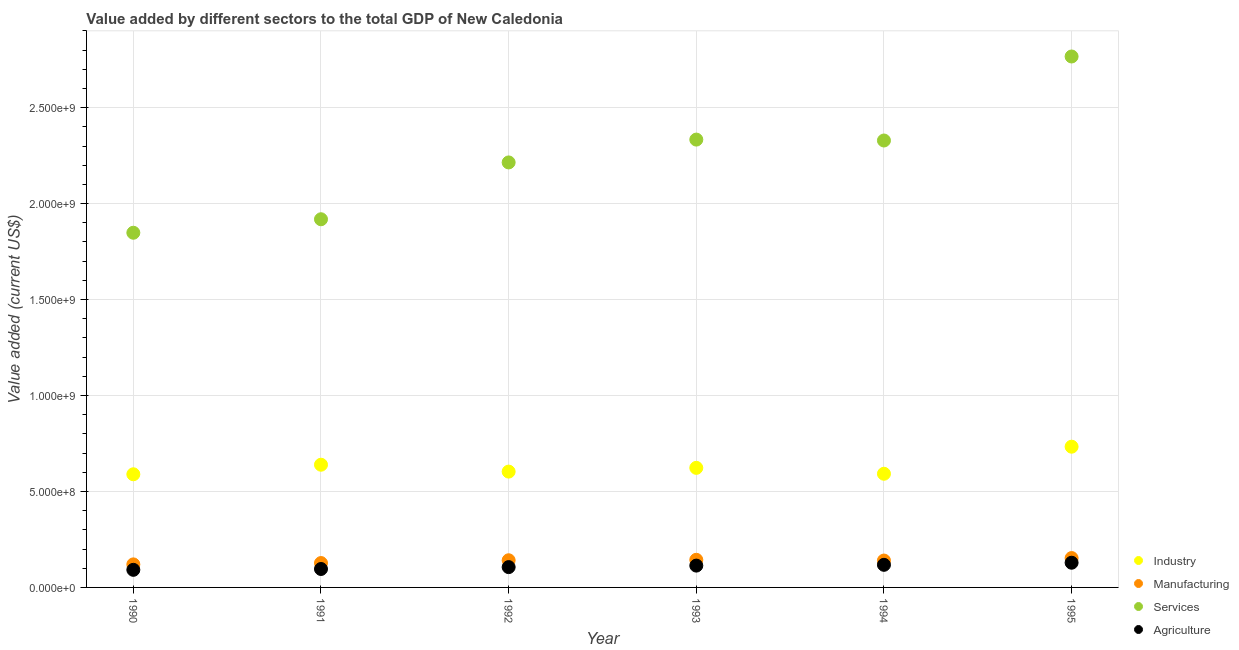What is the value added by services sector in 1993?
Provide a short and direct response. 2.33e+09. Across all years, what is the maximum value added by services sector?
Make the answer very short. 2.77e+09. Across all years, what is the minimum value added by manufacturing sector?
Your answer should be compact. 1.20e+08. In which year was the value added by manufacturing sector maximum?
Offer a terse response. 1995. What is the total value added by industrial sector in the graph?
Your answer should be very brief. 3.78e+09. What is the difference between the value added by services sector in 1991 and that in 1993?
Offer a very short reply. -4.15e+08. What is the difference between the value added by services sector in 1993 and the value added by industrial sector in 1990?
Provide a short and direct response. 1.74e+09. What is the average value added by manufacturing sector per year?
Offer a very short reply. 1.38e+08. In the year 1995, what is the difference between the value added by agricultural sector and value added by services sector?
Your answer should be very brief. -2.64e+09. What is the ratio of the value added by agricultural sector in 1990 to that in 1995?
Your answer should be compact. 0.71. Is the difference between the value added by agricultural sector in 1993 and 1995 greater than the difference between the value added by services sector in 1993 and 1995?
Provide a short and direct response. Yes. What is the difference between the highest and the second highest value added by industrial sector?
Offer a very short reply. 9.39e+07. What is the difference between the highest and the lowest value added by industrial sector?
Your answer should be compact. 1.44e+08. In how many years, is the value added by services sector greater than the average value added by services sector taken over all years?
Give a very brief answer. 3. Is the sum of the value added by manufacturing sector in 1992 and 1993 greater than the maximum value added by agricultural sector across all years?
Your answer should be very brief. Yes. Is it the case that in every year, the sum of the value added by agricultural sector and value added by industrial sector is greater than the sum of value added by manufacturing sector and value added by services sector?
Provide a short and direct response. No. Is it the case that in every year, the sum of the value added by industrial sector and value added by manufacturing sector is greater than the value added by services sector?
Provide a short and direct response. No. Does the value added by manufacturing sector monotonically increase over the years?
Provide a short and direct response. No. How many years are there in the graph?
Your answer should be very brief. 6. What is the difference between two consecutive major ticks on the Y-axis?
Make the answer very short. 5.00e+08. Are the values on the major ticks of Y-axis written in scientific E-notation?
Your answer should be compact. Yes. Does the graph contain any zero values?
Your response must be concise. No. How many legend labels are there?
Your answer should be very brief. 4. What is the title of the graph?
Offer a very short reply. Value added by different sectors to the total GDP of New Caledonia. Does "France" appear as one of the legend labels in the graph?
Give a very brief answer. No. What is the label or title of the Y-axis?
Your answer should be compact. Value added (current US$). What is the Value added (current US$) of Industry in 1990?
Your answer should be compact. 5.90e+08. What is the Value added (current US$) of Manufacturing in 1990?
Ensure brevity in your answer.  1.20e+08. What is the Value added (current US$) in Services in 1990?
Make the answer very short. 1.85e+09. What is the Value added (current US$) of Agriculture in 1990?
Offer a terse response. 9.17e+07. What is the Value added (current US$) of Industry in 1991?
Offer a terse response. 6.39e+08. What is the Value added (current US$) in Manufacturing in 1991?
Make the answer very short. 1.27e+08. What is the Value added (current US$) in Services in 1991?
Your answer should be compact. 1.92e+09. What is the Value added (current US$) in Agriculture in 1991?
Offer a very short reply. 9.60e+07. What is the Value added (current US$) of Industry in 1992?
Provide a short and direct response. 6.03e+08. What is the Value added (current US$) in Manufacturing in 1992?
Keep it short and to the point. 1.42e+08. What is the Value added (current US$) of Services in 1992?
Make the answer very short. 2.21e+09. What is the Value added (current US$) in Agriculture in 1992?
Your answer should be very brief. 1.06e+08. What is the Value added (current US$) of Industry in 1993?
Make the answer very short. 6.23e+08. What is the Value added (current US$) in Manufacturing in 1993?
Your answer should be compact. 1.44e+08. What is the Value added (current US$) in Services in 1993?
Keep it short and to the point. 2.33e+09. What is the Value added (current US$) of Agriculture in 1993?
Keep it short and to the point. 1.14e+08. What is the Value added (current US$) of Industry in 1994?
Offer a terse response. 5.92e+08. What is the Value added (current US$) in Manufacturing in 1994?
Your response must be concise. 1.40e+08. What is the Value added (current US$) in Services in 1994?
Your answer should be compact. 2.33e+09. What is the Value added (current US$) in Agriculture in 1994?
Ensure brevity in your answer.  1.18e+08. What is the Value added (current US$) of Industry in 1995?
Your answer should be compact. 7.33e+08. What is the Value added (current US$) in Manufacturing in 1995?
Your answer should be compact. 1.53e+08. What is the Value added (current US$) of Services in 1995?
Ensure brevity in your answer.  2.77e+09. What is the Value added (current US$) in Agriculture in 1995?
Ensure brevity in your answer.  1.29e+08. Across all years, what is the maximum Value added (current US$) of Industry?
Offer a very short reply. 7.33e+08. Across all years, what is the maximum Value added (current US$) of Manufacturing?
Provide a short and direct response. 1.53e+08. Across all years, what is the maximum Value added (current US$) in Services?
Your response must be concise. 2.77e+09. Across all years, what is the maximum Value added (current US$) of Agriculture?
Make the answer very short. 1.29e+08. Across all years, what is the minimum Value added (current US$) of Industry?
Your answer should be very brief. 5.90e+08. Across all years, what is the minimum Value added (current US$) in Manufacturing?
Offer a terse response. 1.20e+08. Across all years, what is the minimum Value added (current US$) of Services?
Give a very brief answer. 1.85e+09. Across all years, what is the minimum Value added (current US$) in Agriculture?
Keep it short and to the point. 9.17e+07. What is the total Value added (current US$) of Industry in the graph?
Offer a terse response. 3.78e+09. What is the total Value added (current US$) in Manufacturing in the graph?
Offer a very short reply. 8.26e+08. What is the total Value added (current US$) in Services in the graph?
Provide a short and direct response. 1.34e+1. What is the total Value added (current US$) in Agriculture in the graph?
Your answer should be very brief. 6.54e+08. What is the difference between the Value added (current US$) in Industry in 1990 and that in 1991?
Provide a succinct answer. -4.98e+07. What is the difference between the Value added (current US$) of Manufacturing in 1990 and that in 1991?
Your answer should be compact. -6.93e+06. What is the difference between the Value added (current US$) in Services in 1990 and that in 1991?
Provide a short and direct response. -7.03e+07. What is the difference between the Value added (current US$) of Agriculture in 1990 and that in 1991?
Your answer should be compact. -4.37e+06. What is the difference between the Value added (current US$) in Industry in 1990 and that in 1992?
Your answer should be very brief. -1.39e+07. What is the difference between the Value added (current US$) of Manufacturing in 1990 and that in 1992?
Your answer should be compact. -2.15e+07. What is the difference between the Value added (current US$) of Services in 1990 and that in 1992?
Ensure brevity in your answer.  -3.66e+08. What is the difference between the Value added (current US$) in Agriculture in 1990 and that in 1992?
Offer a terse response. -1.42e+07. What is the difference between the Value added (current US$) of Industry in 1990 and that in 1993?
Offer a very short reply. -3.34e+07. What is the difference between the Value added (current US$) of Manufacturing in 1990 and that in 1993?
Offer a terse response. -2.39e+07. What is the difference between the Value added (current US$) of Services in 1990 and that in 1993?
Ensure brevity in your answer.  -4.85e+08. What is the difference between the Value added (current US$) in Agriculture in 1990 and that in 1993?
Provide a short and direct response. -2.20e+07. What is the difference between the Value added (current US$) of Industry in 1990 and that in 1994?
Offer a terse response. -2.67e+06. What is the difference between the Value added (current US$) in Manufacturing in 1990 and that in 1994?
Provide a succinct answer. -2.00e+07. What is the difference between the Value added (current US$) of Services in 1990 and that in 1994?
Offer a terse response. -4.81e+08. What is the difference between the Value added (current US$) in Agriculture in 1990 and that in 1994?
Keep it short and to the point. -2.61e+07. What is the difference between the Value added (current US$) in Industry in 1990 and that in 1995?
Your answer should be very brief. -1.44e+08. What is the difference between the Value added (current US$) in Manufacturing in 1990 and that in 1995?
Provide a succinct answer. -3.29e+07. What is the difference between the Value added (current US$) of Services in 1990 and that in 1995?
Make the answer very short. -9.18e+08. What is the difference between the Value added (current US$) of Agriculture in 1990 and that in 1995?
Make the answer very short. -3.70e+07. What is the difference between the Value added (current US$) in Industry in 1991 and that in 1992?
Ensure brevity in your answer.  3.59e+07. What is the difference between the Value added (current US$) in Manufacturing in 1991 and that in 1992?
Offer a very short reply. -1.45e+07. What is the difference between the Value added (current US$) in Services in 1991 and that in 1992?
Provide a succinct answer. -2.96e+08. What is the difference between the Value added (current US$) of Agriculture in 1991 and that in 1992?
Keep it short and to the point. -9.78e+06. What is the difference between the Value added (current US$) of Industry in 1991 and that in 1993?
Offer a very short reply. 1.64e+07. What is the difference between the Value added (current US$) of Manufacturing in 1991 and that in 1993?
Provide a short and direct response. -1.69e+07. What is the difference between the Value added (current US$) of Services in 1991 and that in 1993?
Provide a succinct answer. -4.15e+08. What is the difference between the Value added (current US$) in Agriculture in 1991 and that in 1993?
Ensure brevity in your answer.  -1.76e+07. What is the difference between the Value added (current US$) in Industry in 1991 and that in 1994?
Your answer should be very brief. 4.71e+07. What is the difference between the Value added (current US$) of Manufacturing in 1991 and that in 1994?
Your response must be concise. -1.31e+07. What is the difference between the Value added (current US$) in Services in 1991 and that in 1994?
Make the answer very short. -4.10e+08. What is the difference between the Value added (current US$) of Agriculture in 1991 and that in 1994?
Provide a short and direct response. -2.17e+07. What is the difference between the Value added (current US$) of Industry in 1991 and that in 1995?
Ensure brevity in your answer.  -9.39e+07. What is the difference between the Value added (current US$) of Manufacturing in 1991 and that in 1995?
Your response must be concise. -2.60e+07. What is the difference between the Value added (current US$) in Services in 1991 and that in 1995?
Provide a succinct answer. -8.48e+08. What is the difference between the Value added (current US$) in Agriculture in 1991 and that in 1995?
Give a very brief answer. -3.27e+07. What is the difference between the Value added (current US$) of Industry in 1992 and that in 1993?
Give a very brief answer. -1.95e+07. What is the difference between the Value added (current US$) in Manufacturing in 1992 and that in 1993?
Make the answer very short. -2.42e+06. What is the difference between the Value added (current US$) in Services in 1992 and that in 1993?
Offer a very short reply. -1.19e+08. What is the difference between the Value added (current US$) in Agriculture in 1992 and that in 1993?
Offer a very short reply. -7.86e+06. What is the difference between the Value added (current US$) of Industry in 1992 and that in 1994?
Make the answer very short. 1.12e+07. What is the difference between the Value added (current US$) of Manufacturing in 1992 and that in 1994?
Ensure brevity in your answer.  1.45e+06. What is the difference between the Value added (current US$) of Services in 1992 and that in 1994?
Offer a terse response. -1.14e+08. What is the difference between the Value added (current US$) in Agriculture in 1992 and that in 1994?
Your response must be concise. -1.20e+07. What is the difference between the Value added (current US$) in Industry in 1992 and that in 1995?
Give a very brief answer. -1.30e+08. What is the difference between the Value added (current US$) in Manufacturing in 1992 and that in 1995?
Offer a very short reply. -1.15e+07. What is the difference between the Value added (current US$) of Services in 1992 and that in 1995?
Ensure brevity in your answer.  -5.52e+08. What is the difference between the Value added (current US$) in Agriculture in 1992 and that in 1995?
Provide a succinct answer. -2.29e+07. What is the difference between the Value added (current US$) in Industry in 1993 and that in 1994?
Your answer should be compact. 3.08e+07. What is the difference between the Value added (current US$) of Manufacturing in 1993 and that in 1994?
Your response must be concise. 3.86e+06. What is the difference between the Value added (current US$) in Services in 1993 and that in 1994?
Your response must be concise. 4.76e+06. What is the difference between the Value added (current US$) in Agriculture in 1993 and that in 1994?
Your answer should be very brief. -4.11e+06. What is the difference between the Value added (current US$) of Industry in 1993 and that in 1995?
Offer a terse response. -1.10e+08. What is the difference between the Value added (current US$) of Manufacturing in 1993 and that in 1995?
Ensure brevity in your answer.  -9.07e+06. What is the difference between the Value added (current US$) in Services in 1993 and that in 1995?
Your response must be concise. -4.33e+08. What is the difference between the Value added (current US$) in Agriculture in 1993 and that in 1995?
Your answer should be very brief. -1.50e+07. What is the difference between the Value added (current US$) in Industry in 1994 and that in 1995?
Give a very brief answer. -1.41e+08. What is the difference between the Value added (current US$) in Manufacturing in 1994 and that in 1995?
Keep it short and to the point. -1.29e+07. What is the difference between the Value added (current US$) in Services in 1994 and that in 1995?
Offer a terse response. -4.38e+08. What is the difference between the Value added (current US$) of Agriculture in 1994 and that in 1995?
Keep it short and to the point. -1.09e+07. What is the difference between the Value added (current US$) of Industry in 1990 and the Value added (current US$) of Manufacturing in 1991?
Keep it short and to the point. 4.63e+08. What is the difference between the Value added (current US$) of Industry in 1990 and the Value added (current US$) of Services in 1991?
Your answer should be compact. -1.33e+09. What is the difference between the Value added (current US$) in Industry in 1990 and the Value added (current US$) in Agriculture in 1991?
Offer a terse response. 4.94e+08. What is the difference between the Value added (current US$) in Manufacturing in 1990 and the Value added (current US$) in Services in 1991?
Make the answer very short. -1.80e+09. What is the difference between the Value added (current US$) in Manufacturing in 1990 and the Value added (current US$) in Agriculture in 1991?
Your response must be concise. 2.40e+07. What is the difference between the Value added (current US$) of Services in 1990 and the Value added (current US$) of Agriculture in 1991?
Your answer should be compact. 1.75e+09. What is the difference between the Value added (current US$) of Industry in 1990 and the Value added (current US$) of Manufacturing in 1992?
Keep it short and to the point. 4.48e+08. What is the difference between the Value added (current US$) in Industry in 1990 and the Value added (current US$) in Services in 1992?
Offer a terse response. -1.62e+09. What is the difference between the Value added (current US$) in Industry in 1990 and the Value added (current US$) in Agriculture in 1992?
Keep it short and to the point. 4.84e+08. What is the difference between the Value added (current US$) of Manufacturing in 1990 and the Value added (current US$) of Services in 1992?
Provide a short and direct response. -2.09e+09. What is the difference between the Value added (current US$) of Manufacturing in 1990 and the Value added (current US$) of Agriculture in 1992?
Your answer should be very brief. 1.43e+07. What is the difference between the Value added (current US$) in Services in 1990 and the Value added (current US$) in Agriculture in 1992?
Offer a very short reply. 1.74e+09. What is the difference between the Value added (current US$) of Industry in 1990 and the Value added (current US$) of Manufacturing in 1993?
Make the answer very short. 4.46e+08. What is the difference between the Value added (current US$) of Industry in 1990 and the Value added (current US$) of Services in 1993?
Make the answer very short. -1.74e+09. What is the difference between the Value added (current US$) in Industry in 1990 and the Value added (current US$) in Agriculture in 1993?
Offer a very short reply. 4.76e+08. What is the difference between the Value added (current US$) of Manufacturing in 1990 and the Value added (current US$) of Services in 1993?
Give a very brief answer. -2.21e+09. What is the difference between the Value added (current US$) of Manufacturing in 1990 and the Value added (current US$) of Agriculture in 1993?
Offer a terse response. 6.40e+06. What is the difference between the Value added (current US$) of Services in 1990 and the Value added (current US$) of Agriculture in 1993?
Give a very brief answer. 1.73e+09. What is the difference between the Value added (current US$) of Industry in 1990 and the Value added (current US$) of Manufacturing in 1994?
Give a very brief answer. 4.49e+08. What is the difference between the Value added (current US$) of Industry in 1990 and the Value added (current US$) of Services in 1994?
Offer a terse response. -1.74e+09. What is the difference between the Value added (current US$) of Industry in 1990 and the Value added (current US$) of Agriculture in 1994?
Your answer should be compact. 4.72e+08. What is the difference between the Value added (current US$) of Manufacturing in 1990 and the Value added (current US$) of Services in 1994?
Offer a very short reply. -2.21e+09. What is the difference between the Value added (current US$) of Manufacturing in 1990 and the Value added (current US$) of Agriculture in 1994?
Offer a terse response. 2.29e+06. What is the difference between the Value added (current US$) of Services in 1990 and the Value added (current US$) of Agriculture in 1994?
Offer a terse response. 1.73e+09. What is the difference between the Value added (current US$) of Industry in 1990 and the Value added (current US$) of Manufacturing in 1995?
Provide a succinct answer. 4.37e+08. What is the difference between the Value added (current US$) of Industry in 1990 and the Value added (current US$) of Services in 1995?
Provide a short and direct response. -2.18e+09. What is the difference between the Value added (current US$) of Industry in 1990 and the Value added (current US$) of Agriculture in 1995?
Give a very brief answer. 4.61e+08. What is the difference between the Value added (current US$) in Manufacturing in 1990 and the Value added (current US$) in Services in 1995?
Your answer should be compact. -2.65e+09. What is the difference between the Value added (current US$) in Manufacturing in 1990 and the Value added (current US$) in Agriculture in 1995?
Ensure brevity in your answer.  -8.63e+06. What is the difference between the Value added (current US$) of Services in 1990 and the Value added (current US$) of Agriculture in 1995?
Provide a short and direct response. 1.72e+09. What is the difference between the Value added (current US$) of Industry in 1991 and the Value added (current US$) of Manufacturing in 1992?
Keep it short and to the point. 4.98e+08. What is the difference between the Value added (current US$) in Industry in 1991 and the Value added (current US$) in Services in 1992?
Give a very brief answer. -1.58e+09. What is the difference between the Value added (current US$) in Industry in 1991 and the Value added (current US$) in Agriculture in 1992?
Your answer should be very brief. 5.34e+08. What is the difference between the Value added (current US$) in Manufacturing in 1991 and the Value added (current US$) in Services in 1992?
Offer a terse response. -2.09e+09. What is the difference between the Value added (current US$) in Manufacturing in 1991 and the Value added (current US$) in Agriculture in 1992?
Provide a short and direct response. 2.12e+07. What is the difference between the Value added (current US$) of Services in 1991 and the Value added (current US$) of Agriculture in 1992?
Give a very brief answer. 1.81e+09. What is the difference between the Value added (current US$) in Industry in 1991 and the Value added (current US$) in Manufacturing in 1993?
Your response must be concise. 4.95e+08. What is the difference between the Value added (current US$) in Industry in 1991 and the Value added (current US$) in Services in 1993?
Your answer should be compact. -1.69e+09. What is the difference between the Value added (current US$) in Industry in 1991 and the Value added (current US$) in Agriculture in 1993?
Offer a terse response. 5.26e+08. What is the difference between the Value added (current US$) of Manufacturing in 1991 and the Value added (current US$) of Services in 1993?
Keep it short and to the point. -2.21e+09. What is the difference between the Value added (current US$) in Manufacturing in 1991 and the Value added (current US$) in Agriculture in 1993?
Provide a succinct answer. 1.33e+07. What is the difference between the Value added (current US$) of Services in 1991 and the Value added (current US$) of Agriculture in 1993?
Keep it short and to the point. 1.80e+09. What is the difference between the Value added (current US$) in Industry in 1991 and the Value added (current US$) in Manufacturing in 1994?
Give a very brief answer. 4.99e+08. What is the difference between the Value added (current US$) in Industry in 1991 and the Value added (current US$) in Services in 1994?
Provide a succinct answer. -1.69e+09. What is the difference between the Value added (current US$) of Industry in 1991 and the Value added (current US$) of Agriculture in 1994?
Provide a short and direct response. 5.22e+08. What is the difference between the Value added (current US$) in Manufacturing in 1991 and the Value added (current US$) in Services in 1994?
Your response must be concise. -2.20e+09. What is the difference between the Value added (current US$) of Manufacturing in 1991 and the Value added (current US$) of Agriculture in 1994?
Your answer should be compact. 9.22e+06. What is the difference between the Value added (current US$) in Services in 1991 and the Value added (current US$) in Agriculture in 1994?
Keep it short and to the point. 1.80e+09. What is the difference between the Value added (current US$) of Industry in 1991 and the Value added (current US$) of Manufacturing in 1995?
Your answer should be very brief. 4.86e+08. What is the difference between the Value added (current US$) in Industry in 1991 and the Value added (current US$) in Services in 1995?
Offer a terse response. -2.13e+09. What is the difference between the Value added (current US$) of Industry in 1991 and the Value added (current US$) of Agriculture in 1995?
Offer a very short reply. 5.11e+08. What is the difference between the Value added (current US$) of Manufacturing in 1991 and the Value added (current US$) of Services in 1995?
Your answer should be very brief. -2.64e+09. What is the difference between the Value added (current US$) of Manufacturing in 1991 and the Value added (current US$) of Agriculture in 1995?
Keep it short and to the point. -1.70e+06. What is the difference between the Value added (current US$) of Services in 1991 and the Value added (current US$) of Agriculture in 1995?
Your answer should be very brief. 1.79e+09. What is the difference between the Value added (current US$) of Industry in 1992 and the Value added (current US$) of Manufacturing in 1993?
Provide a short and direct response. 4.60e+08. What is the difference between the Value added (current US$) in Industry in 1992 and the Value added (current US$) in Services in 1993?
Your response must be concise. -1.73e+09. What is the difference between the Value added (current US$) of Industry in 1992 and the Value added (current US$) of Agriculture in 1993?
Keep it short and to the point. 4.90e+08. What is the difference between the Value added (current US$) in Manufacturing in 1992 and the Value added (current US$) in Services in 1993?
Make the answer very short. -2.19e+09. What is the difference between the Value added (current US$) of Manufacturing in 1992 and the Value added (current US$) of Agriculture in 1993?
Provide a succinct answer. 2.79e+07. What is the difference between the Value added (current US$) in Services in 1992 and the Value added (current US$) in Agriculture in 1993?
Your answer should be compact. 2.10e+09. What is the difference between the Value added (current US$) of Industry in 1992 and the Value added (current US$) of Manufacturing in 1994?
Ensure brevity in your answer.  4.63e+08. What is the difference between the Value added (current US$) of Industry in 1992 and the Value added (current US$) of Services in 1994?
Ensure brevity in your answer.  -1.73e+09. What is the difference between the Value added (current US$) of Industry in 1992 and the Value added (current US$) of Agriculture in 1994?
Provide a succinct answer. 4.86e+08. What is the difference between the Value added (current US$) in Manufacturing in 1992 and the Value added (current US$) in Services in 1994?
Your response must be concise. -2.19e+09. What is the difference between the Value added (current US$) of Manufacturing in 1992 and the Value added (current US$) of Agriculture in 1994?
Ensure brevity in your answer.  2.37e+07. What is the difference between the Value added (current US$) of Services in 1992 and the Value added (current US$) of Agriculture in 1994?
Give a very brief answer. 2.10e+09. What is the difference between the Value added (current US$) in Industry in 1992 and the Value added (current US$) in Manufacturing in 1995?
Make the answer very short. 4.50e+08. What is the difference between the Value added (current US$) of Industry in 1992 and the Value added (current US$) of Services in 1995?
Keep it short and to the point. -2.16e+09. What is the difference between the Value added (current US$) of Industry in 1992 and the Value added (current US$) of Agriculture in 1995?
Offer a very short reply. 4.75e+08. What is the difference between the Value added (current US$) in Manufacturing in 1992 and the Value added (current US$) in Services in 1995?
Your answer should be compact. -2.62e+09. What is the difference between the Value added (current US$) of Manufacturing in 1992 and the Value added (current US$) of Agriculture in 1995?
Your answer should be very brief. 1.28e+07. What is the difference between the Value added (current US$) of Services in 1992 and the Value added (current US$) of Agriculture in 1995?
Make the answer very short. 2.09e+09. What is the difference between the Value added (current US$) in Industry in 1993 and the Value added (current US$) in Manufacturing in 1994?
Keep it short and to the point. 4.83e+08. What is the difference between the Value added (current US$) in Industry in 1993 and the Value added (current US$) in Services in 1994?
Offer a terse response. -1.71e+09. What is the difference between the Value added (current US$) of Industry in 1993 and the Value added (current US$) of Agriculture in 1994?
Give a very brief answer. 5.05e+08. What is the difference between the Value added (current US$) in Manufacturing in 1993 and the Value added (current US$) in Services in 1994?
Your answer should be compact. -2.18e+09. What is the difference between the Value added (current US$) of Manufacturing in 1993 and the Value added (current US$) of Agriculture in 1994?
Ensure brevity in your answer.  2.62e+07. What is the difference between the Value added (current US$) of Services in 1993 and the Value added (current US$) of Agriculture in 1994?
Your answer should be very brief. 2.22e+09. What is the difference between the Value added (current US$) of Industry in 1993 and the Value added (current US$) of Manufacturing in 1995?
Give a very brief answer. 4.70e+08. What is the difference between the Value added (current US$) of Industry in 1993 and the Value added (current US$) of Services in 1995?
Keep it short and to the point. -2.14e+09. What is the difference between the Value added (current US$) of Industry in 1993 and the Value added (current US$) of Agriculture in 1995?
Offer a very short reply. 4.94e+08. What is the difference between the Value added (current US$) of Manufacturing in 1993 and the Value added (current US$) of Services in 1995?
Provide a succinct answer. -2.62e+09. What is the difference between the Value added (current US$) in Manufacturing in 1993 and the Value added (current US$) in Agriculture in 1995?
Provide a short and direct response. 1.52e+07. What is the difference between the Value added (current US$) in Services in 1993 and the Value added (current US$) in Agriculture in 1995?
Your answer should be very brief. 2.20e+09. What is the difference between the Value added (current US$) of Industry in 1994 and the Value added (current US$) of Manufacturing in 1995?
Keep it short and to the point. 4.39e+08. What is the difference between the Value added (current US$) of Industry in 1994 and the Value added (current US$) of Services in 1995?
Provide a short and direct response. -2.17e+09. What is the difference between the Value added (current US$) in Industry in 1994 and the Value added (current US$) in Agriculture in 1995?
Ensure brevity in your answer.  4.64e+08. What is the difference between the Value added (current US$) of Manufacturing in 1994 and the Value added (current US$) of Services in 1995?
Make the answer very short. -2.63e+09. What is the difference between the Value added (current US$) in Manufacturing in 1994 and the Value added (current US$) in Agriculture in 1995?
Offer a very short reply. 1.14e+07. What is the difference between the Value added (current US$) of Services in 1994 and the Value added (current US$) of Agriculture in 1995?
Keep it short and to the point. 2.20e+09. What is the average Value added (current US$) of Industry per year?
Provide a succinct answer. 6.30e+08. What is the average Value added (current US$) of Manufacturing per year?
Make the answer very short. 1.38e+08. What is the average Value added (current US$) of Services per year?
Your answer should be very brief. 2.23e+09. What is the average Value added (current US$) in Agriculture per year?
Provide a succinct answer. 1.09e+08. In the year 1990, what is the difference between the Value added (current US$) of Industry and Value added (current US$) of Manufacturing?
Your answer should be very brief. 4.69e+08. In the year 1990, what is the difference between the Value added (current US$) of Industry and Value added (current US$) of Services?
Offer a terse response. -1.26e+09. In the year 1990, what is the difference between the Value added (current US$) of Industry and Value added (current US$) of Agriculture?
Offer a very short reply. 4.98e+08. In the year 1990, what is the difference between the Value added (current US$) of Manufacturing and Value added (current US$) of Services?
Your answer should be compact. -1.73e+09. In the year 1990, what is the difference between the Value added (current US$) in Manufacturing and Value added (current US$) in Agriculture?
Make the answer very short. 2.84e+07. In the year 1990, what is the difference between the Value added (current US$) of Services and Value added (current US$) of Agriculture?
Give a very brief answer. 1.76e+09. In the year 1991, what is the difference between the Value added (current US$) in Industry and Value added (current US$) in Manufacturing?
Make the answer very short. 5.12e+08. In the year 1991, what is the difference between the Value added (current US$) in Industry and Value added (current US$) in Services?
Your answer should be very brief. -1.28e+09. In the year 1991, what is the difference between the Value added (current US$) in Industry and Value added (current US$) in Agriculture?
Your response must be concise. 5.43e+08. In the year 1991, what is the difference between the Value added (current US$) in Manufacturing and Value added (current US$) in Services?
Keep it short and to the point. -1.79e+09. In the year 1991, what is the difference between the Value added (current US$) in Manufacturing and Value added (current US$) in Agriculture?
Offer a very short reply. 3.10e+07. In the year 1991, what is the difference between the Value added (current US$) in Services and Value added (current US$) in Agriculture?
Provide a short and direct response. 1.82e+09. In the year 1992, what is the difference between the Value added (current US$) of Industry and Value added (current US$) of Manufacturing?
Your answer should be very brief. 4.62e+08. In the year 1992, what is the difference between the Value added (current US$) of Industry and Value added (current US$) of Services?
Ensure brevity in your answer.  -1.61e+09. In the year 1992, what is the difference between the Value added (current US$) in Industry and Value added (current US$) in Agriculture?
Provide a short and direct response. 4.98e+08. In the year 1992, what is the difference between the Value added (current US$) of Manufacturing and Value added (current US$) of Services?
Keep it short and to the point. -2.07e+09. In the year 1992, what is the difference between the Value added (current US$) of Manufacturing and Value added (current US$) of Agriculture?
Keep it short and to the point. 3.57e+07. In the year 1992, what is the difference between the Value added (current US$) of Services and Value added (current US$) of Agriculture?
Provide a succinct answer. 2.11e+09. In the year 1993, what is the difference between the Value added (current US$) in Industry and Value added (current US$) in Manufacturing?
Your response must be concise. 4.79e+08. In the year 1993, what is the difference between the Value added (current US$) of Industry and Value added (current US$) of Services?
Provide a short and direct response. -1.71e+09. In the year 1993, what is the difference between the Value added (current US$) of Industry and Value added (current US$) of Agriculture?
Offer a terse response. 5.09e+08. In the year 1993, what is the difference between the Value added (current US$) of Manufacturing and Value added (current US$) of Services?
Give a very brief answer. -2.19e+09. In the year 1993, what is the difference between the Value added (current US$) in Manufacturing and Value added (current US$) in Agriculture?
Offer a very short reply. 3.03e+07. In the year 1993, what is the difference between the Value added (current US$) of Services and Value added (current US$) of Agriculture?
Give a very brief answer. 2.22e+09. In the year 1994, what is the difference between the Value added (current US$) in Industry and Value added (current US$) in Manufacturing?
Provide a succinct answer. 4.52e+08. In the year 1994, what is the difference between the Value added (current US$) of Industry and Value added (current US$) of Services?
Keep it short and to the point. -1.74e+09. In the year 1994, what is the difference between the Value added (current US$) in Industry and Value added (current US$) in Agriculture?
Offer a very short reply. 4.74e+08. In the year 1994, what is the difference between the Value added (current US$) in Manufacturing and Value added (current US$) in Services?
Offer a very short reply. -2.19e+09. In the year 1994, what is the difference between the Value added (current US$) of Manufacturing and Value added (current US$) of Agriculture?
Ensure brevity in your answer.  2.23e+07. In the year 1994, what is the difference between the Value added (current US$) in Services and Value added (current US$) in Agriculture?
Give a very brief answer. 2.21e+09. In the year 1995, what is the difference between the Value added (current US$) of Industry and Value added (current US$) of Manufacturing?
Provide a succinct answer. 5.80e+08. In the year 1995, what is the difference between the Value added (current US$) of Industry and Value added (current US$) of Services?
Keep it short and to the point. -2.03e+09. In the year 1995, what is the difference between the Value added (current US$) of Industry and Value added (current US$) of Agriculture?
Give a very brief answer. 6.05e+08. In the year 1995, what is the difference between the Value added (current US$) of Manufacturing and Value added (current US$) of Services?
Provide a short and direct response. -2.61e+09. In the year 1995, what is the difference between the Value added (current US$) of Manufacturing and Value added (current US$) of Agriculture?
Keep it short and to the point. 2.43e+07. In the year 1995, what is the difference between the Value added (current US$) of Services and Value added (current US$) of Agriculture?
Your response must be concise. 2.64e+09. What is the ratio of the Value added (current US$) of Industry in 1990 to that in 1991?
Ensure brevity in your answer.  0.92. What is the ratio of the Value added (current US$) in Manufacturing in 1990 to that in 1991?
Offer a terse response. 0.95. What is the ratio of the Value added (current US$) in Services in 1990 to that in 1991?
Ensure brevity in your answer.  0.96. What is the ratio of the Value added (current US$) in Agriculture in 1990 to that in 1991?
Provide a short and direct response. 0.95. What is the ratio of the Value added (current US$) in Manufacturing in 1990 to that in 1992?
Provide a short and direct response. 0.85. What is the ratio of the Value added (current US$) in Services in 1990 to that in 1992?
Offer a very short reply. 0.83. What is the ratio of the Value added (current US$) of Agriculture in 1990 to that in 1992?
Your answer should be very brief. 0.87. What is the ratio of the Value added (current US$) in Industry in 1990 to that in 1993?
Offer a terse response. 0.95. What is the ratio of the Value added (current US$) in Manufacturing in 1990 to that in 1993?
Give a very brief answer. 0.83. What is the ratio of the Value added (current US$) of Services in 1990 to that in 1993?
Give a very brief answer. 0.79. What is the ratio of the Value added (current US$) in Agriculture in 1990 to that in 1993?
Provide a short and direct response. 0.81. What is the ratio of the Value added (current US$) of Manufacturing in 1990 to that in 1994?
Offer a very short reply. 0.86. What is the ratio of the Value added (current US$) in Services in 1990 to that in 1994?
Provide a short and direct response. 0.79. What is the ratio of the Value added (current US$) of Agriculture in 1990 to that in 1994?
Ensure brevity in your answer.  0.78. What is the ratio of the Value added (current US$) in Industry in 1990 to that in 1995?
Offer a terse response. 0.8. What is the ratio of the Value added (current US$) in Manufacturing in 1990 to that in 1995?
Provide a short and direct response. 0.78. What is the ratio of the Value added (current US$) of Services in 1990 to that in 1995?
Your answer should be compact. 0.67. What is the ratio of the Value added (current US$) of Agriculture in 1990 to that in 1995?
Your answer should be very brief. 0.71. What is the ratio of the Value added (current US$) in Industry in 1991 to that in 1992?
Ensure brevity in your answer.  1.06. What is the ratio of the Value added (current US$) in Manufacturing in 1991 to that in 1992?
Offer a terse response. 0.9. What is the ratio of the Value added (current US$) of Services in 1991 to that in 1992?
Ensure brevity in your answer.  0.87. What is the ratio of the Value added (current US$) of Agriculture in 1991 to that in 1992?
Provide a short and direct response. 0.91. What is the ratio of the Value added (current US$) in Industry in 1991 to that in 1993?
Give a very brief answer. 1.03. What is the ratio of the Value added (current US$) of Manufacturing in 1991 to that in 1993?
Your response must be concise. 0.88. What is the ratio of the Value added (current US$) in Services in 1991 to that in 1993?
Give a very brief answer. 0.82. What is the ratio of the Value added (current US$) in Agriculture in 1991 to that in 1993?
Offer a terse response. 0.84. What is the ratio of the Value added (current US$) in Industry in 1991 to that in 1994?
Offer a terse response. 1.08. What is the ratio of the Value added (current US$) in Manufacturing in 1991 to that in 1994?
Your answer should be very brief. 0.91. What is the ratio of the Value added (current US$) in Services in 1991 to that in 1994?
Ensure brevity in your answer.  0.82. What is the ratio of the Value added (current US$) of Agriculture in 1991 to that in 1994?
Offer a terse response. 0.82. What is the ratio of the Value added (current US$) of Industry in 1991 to that in 1995?
Keep it short and to the point. 0.87. What is the ratio of the Value added (current US$) of Manufacturing in 1991 to that in 1995?
Your answer should be compact. 0.83. What is the ratio of the Value added (current US$) of Services in 1991 to that in 1995?
Provide a short and direct response. 0.69. What is the ratio of the Value added (current US$) of Agriculture in 1991 to that in 1995?
Give a very brief answer. 0.75. What is the ratio of the Value added (current US$) of Industry in 1992 to that in 1993?
Offer a very short reply. 0.97. What is the ratio of the Value added (current US$) in Manufacturing in 1992 to that in 1993?
Make the answer very short. 0.98. What is the ratio of the Value added (current US$) in Services in 1992 to that in 1993?
Your answer should be very brief. 0.95. What is the ratio of the Value added (current US$) in Agriculture in 1992 to that in 1993?
Offer a very short reply. 0.93. What is the ratio of the Value added (current US$) in Manufacturing in 1992 to that in 1994?
Your answer should be very brief. 1.01. What is the ratio of the Value added (current US$) of Services in 1992 to that in 1994?
Offer a very short reply. 0.95. What is the ratio of the Value added (current US$) of Agriculture in 1992 to that in 1994?
Provide a short and direct response. 0.9. What is the ratio of the Value added (current US$) in Industry in 1992 to that in 1995?
Keep it short and to the point. 0.82. What is the ratio of the Value added (current US$) in Manufacturing in 1992 to that in 1995?
Offer a terse response. 0.92. What is the ratio of the Value added (current US$) of Services in 1992 to that in 1995?
Keep it short and to the point. 0.8. What is the ratio of the Value added (current US$) in Agriculture in 1992 to that in 1995?
Your answer should be very brief. 0.82. What is the ratio of the Value added (current US$) in Industry in 1993 to that in 1994?
Provide a short and direct response. 1.05. What is the ratio of the Value added (current US$) of Manufacturing in 1993 to that in 1994?
Offer a very short reply. 1.03. What is the ratio of the Value added (current US$) of Agriculture in 1993 to that in 1994?
Offer a very short reply. 0.97. What is the ratio of the Value added (current US$) in Industry in 1993 to that in 1995?
Ensure brevity in your answer.  0.85. What is the ratio of the Value added (current US$) of Manufacturing in 1993 to that in 1995?
Provide a succinct answer. 0.94. What is the ratio of the Value added (current US$) in Services in 1993 to that in 1995?
Give a very brief answer. 0.84. What is the ratio of the Value added (current US$) of Agriculture in 1993 to that in 1995?
Your answer should be very brief. 0.88. What is the ratio of the Value added (current US$) of Industry in 1994 to that in 1995?
Your response must be concise. 0.81. What is the ratio of the Value added (current US$) of Manufacturing in 1994 to that in 1995?
Provide a succinct answer. 0.92. What is the ratio of the Value added (current US$) of Services in 1994 to that in 1995?
Keep it short and to the point. 0.84. What is the ratio of the Value added (current US$) in Agriculture in 1994 to that in 1995?
Your answer should be compact. 0.92. What is the difference between the highest and the second highest Value added (current US$) in Industry?
Provide a succinct answer. 9.39e+07. What is the difference between the highest and the second highest Value added (current US$) in Manufacturing?
Provide a succinct answer. 9.07e+06. What is the difference between the highest and the second highest Value added (current US$) of Services?
Provide a short and direct response. 4.33e+08. What is the difference between the highest and the second highest Value added (current US$) in Agriculture?
Your answer should be very brief. 1.09e+07. What is the difference between the highest and the lowest Value added (current US$) in Industry?
Keep it short and to the point. 1.44e+08. What is the difference between the highest and the lowest Value added (current US$) of Manufacturing?
Ensure brevity in your answer.  3.29e+07. What is the difference between the highest and the lowest Value added (current US$) of Services?
Your answer should be compact. 9.18e+08. What is the difference between the highest and the lowest Value added (current US$) of Agriculture?
Offer a very short reply. 3.70e+07. 